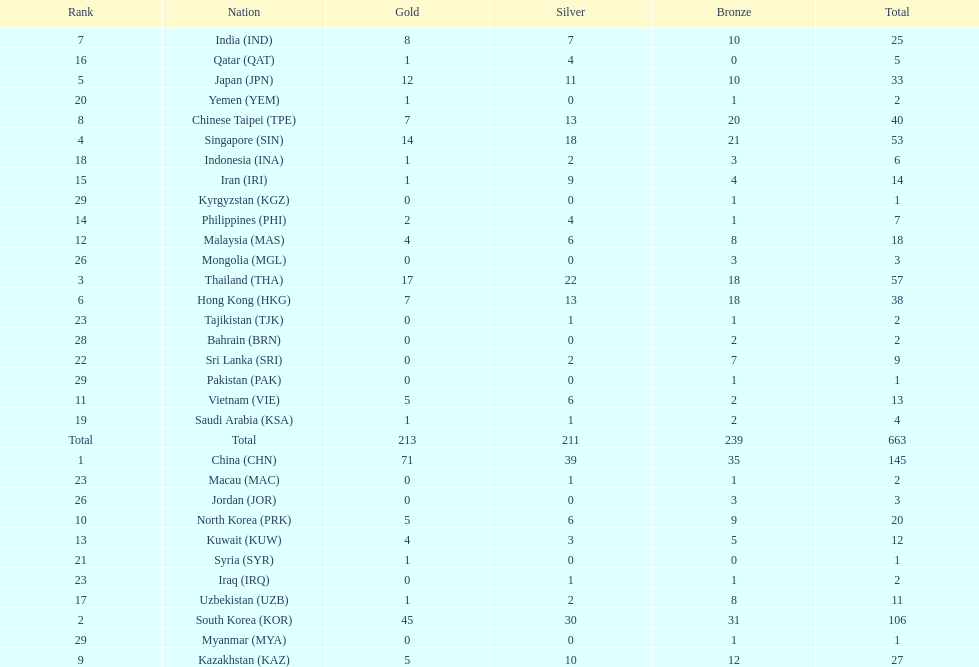How many countries have at least 10 gold medals in the asian youth games? 5. 